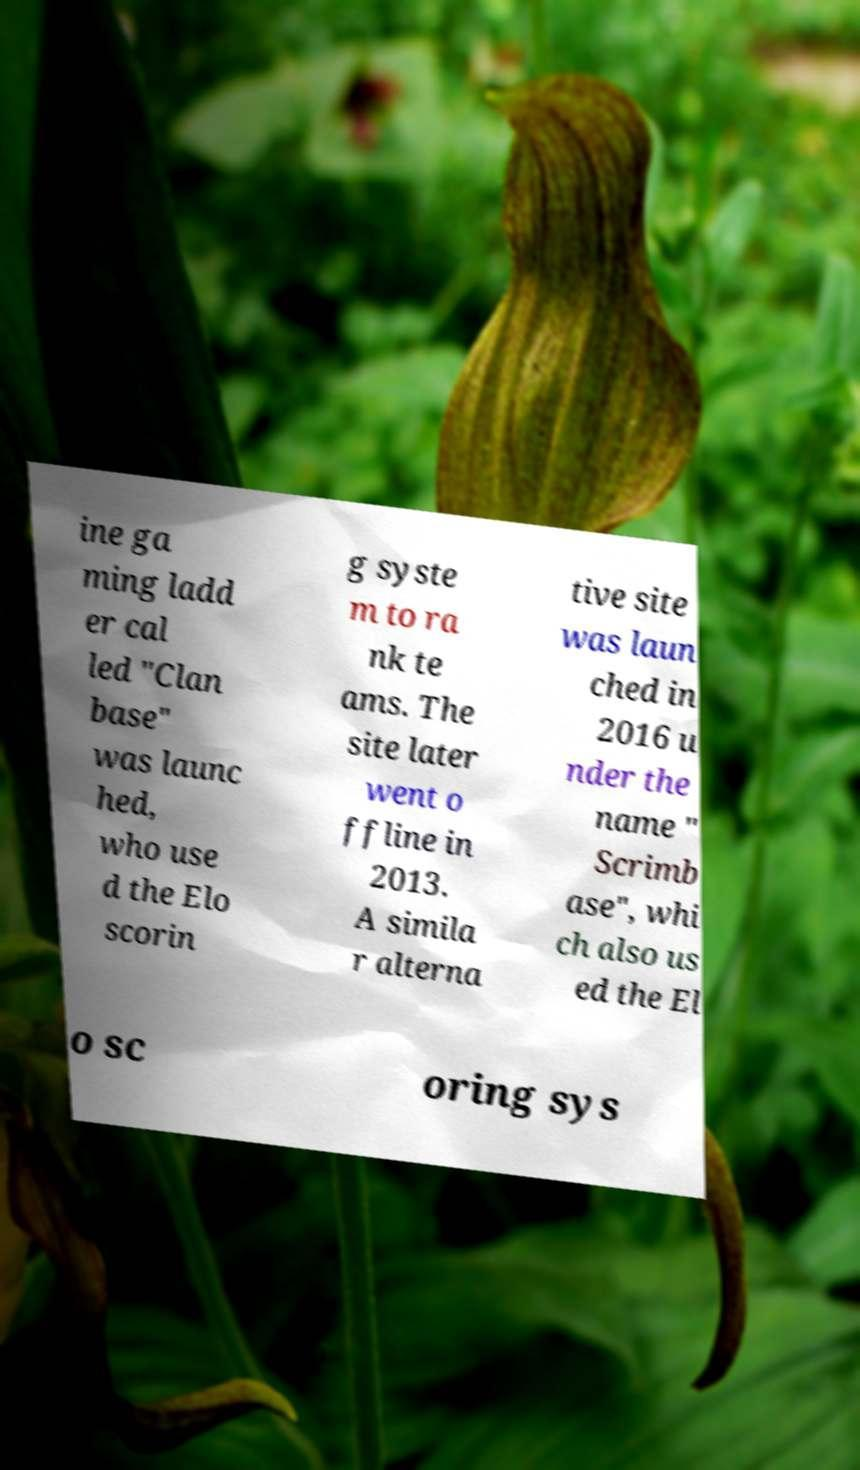Can you read and provide the text displayed in the image?This photo seems to have some interesting text. Can you extract and type it out for me? ine ga ming ladd er cal led "Clan base" was launc hed, who use d the Elo scorin g syste m to ra nk te ams. The site later went o ffline in 2013. A simila r alterna tive site was laun ched in 2016 u nder the name " Scrimb ase", whi ch also us ed the El o sc oring sys 